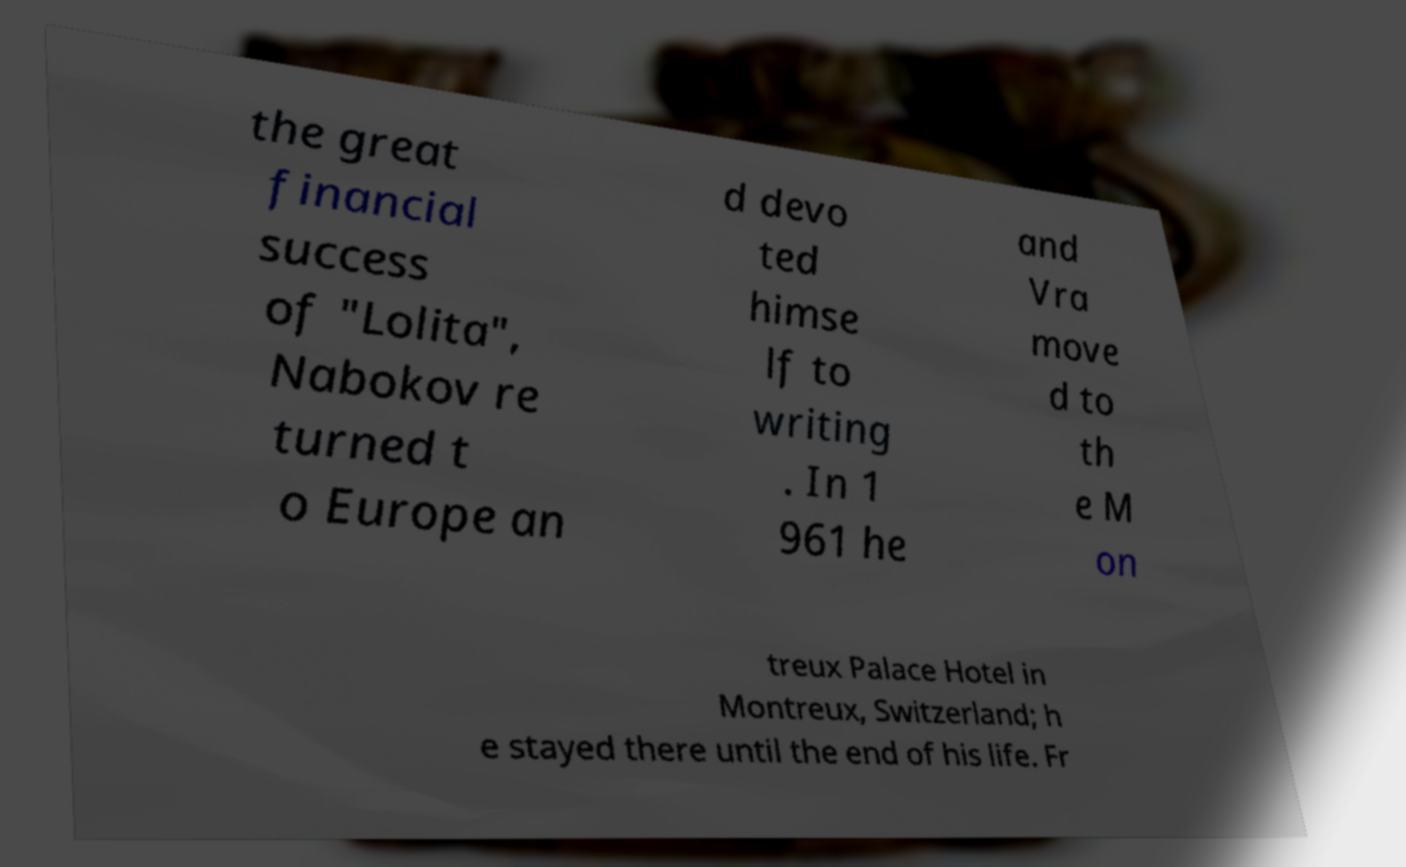For documentation purposes, I need the text within this image transcribed. Could you provide that? the great financial success of "Lolita", Nabokov re turned t o Europe an d devo ted himse lf to writing . In 1 961 he and Vra move d to th e M on treux Palace Hotel in Montreux, Switzerland; h e stayed there until the end of his life. Fr 